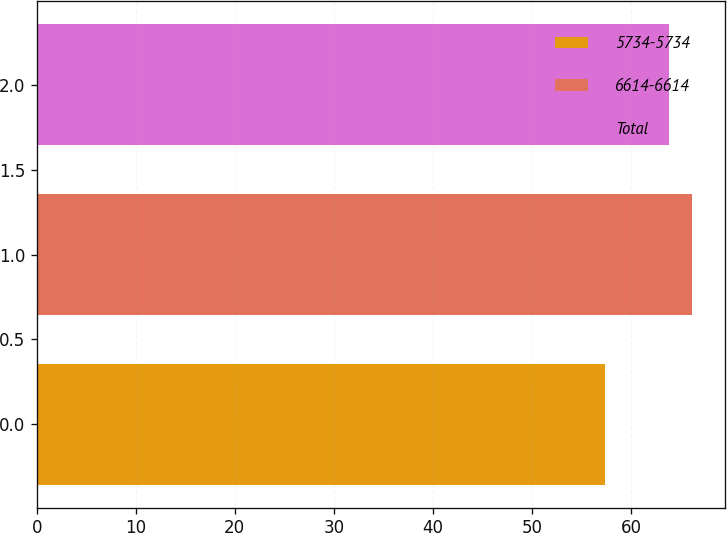<chart> <loc_0><loc_0><loc_500><loc_500><bar_chart><fcel>5734-5734<fcel>6614-6614<fcel>Total<nl><fcel>57.34<fcel>66.14<fcel>63.84<nl></chart> 